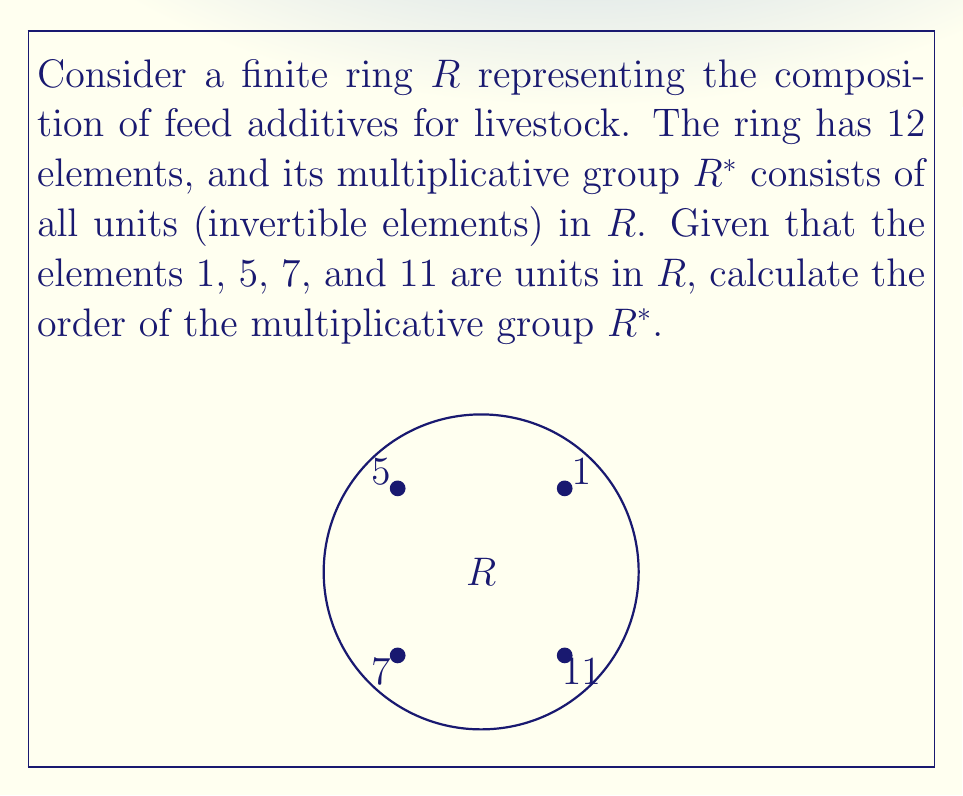Give your solution to this math problem. To solve this problem, we need to follow these steps:

1) First, recall that in a finite ring, the order of the multiplicative group $R^*$ is equal to the number of units in the ring.

2) We are given that the elements 1, 5, 7, and 11 are units in $R$. Let's count these:
   $$|R^*| \geq 4$$

3) In any ring, 1 is always a unit. The fact that 5, 7, and 11 are also units suggests that this ring might be $\mathbb{Z}_{12}$, the ring of integers modulo 12.

4) In $\mathbb{Z}_{12}$, an element is a unit if and only if it is coprime to 12. The elements coprime to 12 are 1, 5, 7, and 11.

5) Therefore, our assumption that $R \cong \mathbb{Z}_{12}$ is correct, and we have found all the units in $R$.

6) The order of $R^*$ is thus equal to the number of units we found:
   $$|R^*| = 4$$

This result is consistent with the Euler totient function $\phi(12) = 4$, which gives the number of integers less than 12 that are coprime to 12.
Answer: $|R^*| = 4$ 